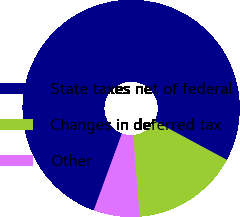Convert chart. <chart><loc_0><loc_0><loc_500><loc_500><pie_chart><fcel>State taxes net of federal<fcel>Changes in deferred tax<fcel>Other<nl><fcel>77.27%<fcel>15.91%<fcel>6.82%<nl></chart> 